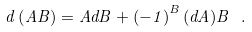<formula> <loc_0><loc_0><loc_500><loc_500>d \left ( A B \right ) = A d B + \left ( - 1 \right ) ^ { B } ( d A ) B \ .</formula> 